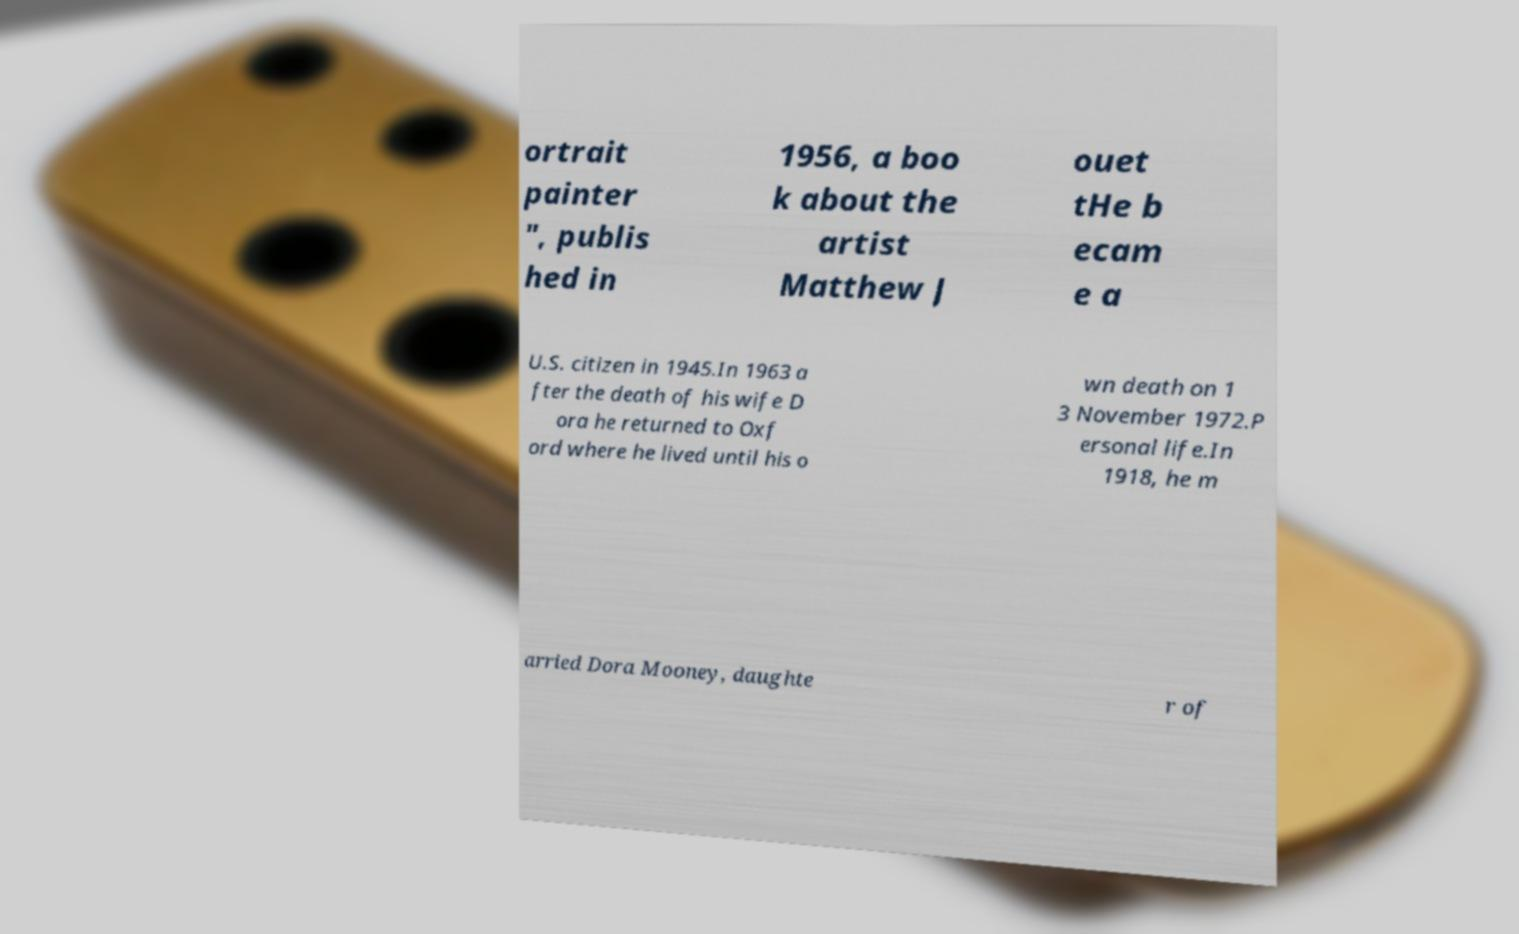Could you assist in decoding the text presented in this image and type it out clearly? ortrait painter ", publis hed in 1956, a boo k about the artist Matthew J ouet tHe b ecam e a U.S. citizen in 1945.In 1963 a fter the death of his wife D ora he returned to Oxf ord where he lived until his o wn death on 1 3 November 1972.P ersonal life.In 1918, he m arried Dora Mooney, daughte r of 